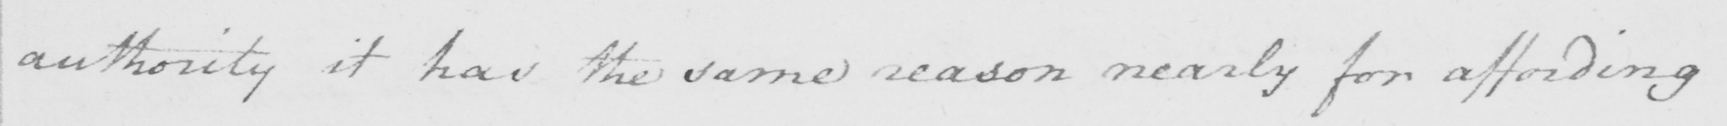Can you read and transcribe this handwriting? authority it has the same reason nearly for affording 